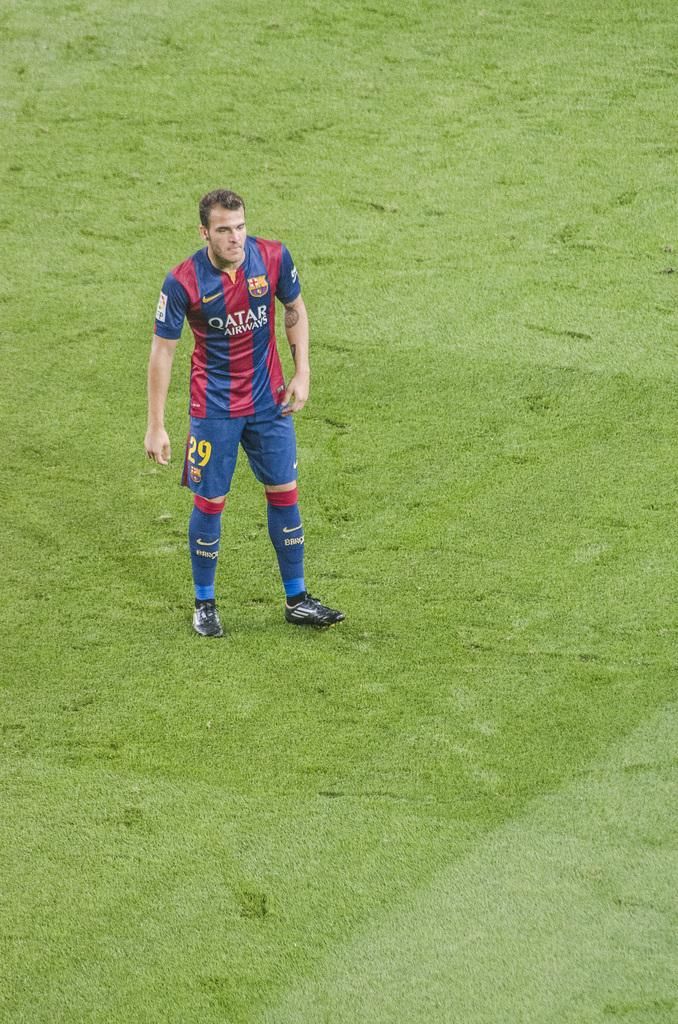Where was the picture taken? The picture was clicked outside. What is the main subject of the image? There is a person in the center of the image. What is the person wearing? The person is wearing a t-shirt. What is the person standing on? The person is standing on the ground. What is the ground covered with? The ground is covered with green grass. How many wrens can be seen flying in the image? There are no wrens present in the image. What type of deer is visible in the background of the image? There are no deer present in the image. 